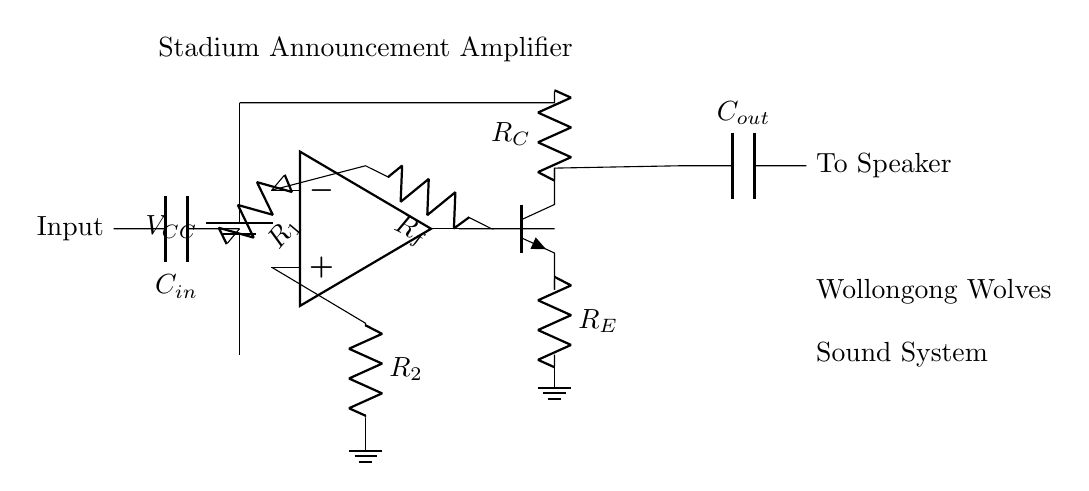What is the power supply voltage? The circuit shows a battery labeled as VCC, which indicates the power supply voltage is provided by this battery. It is often a standard voltage, commonly 5V or 12V in amplifier circuits.
Answer: VCC What type of amplifier is represented in this circuit? The diagram features an operational amplifier, which is indicated by the op amp symbol. This type of amplifier is commonly used for signal amplification.
Answer: Operational amplifier What are the values of R1 and R2 in the circuit? The diagram shows resistors R1 and R2 connected to the input stage of the operational amplifier, but specific resistance values are not indicated directly in the diagram, which may need external reference or data for specification.
Answer: Not specified How is the output connected to the speaker? The output of the transistor is connected through a capacitor labeled Cout, which serves as a coupling capacitor to provide AC signal to the speaker while blocking DC.
Answer: Through Cout What is the purpose of the feedback resistor, Rf? The feedback resistor Rf is used to set the gain of the operational amplifier. The feedback allows the operational amplifier to stabilize and be configured for its desired amplification levels.
Answer: Set gain What components are used in the input stage? The input stage consists of the operational amplifier, resistor R1, resistor R2, and capacitor Cin. These components work together to process the input signal before amplification.
Answer: Op amp, R1, R2, Cin How does this circuit ensure sound clarity for announcements? The inclusion of capacitors, resistors, and the operational amplifier ensures filtering and amplifying the input signal to provide a clear output to the speakers, thus enhancing clarity.
Answer: Filtering and amplification 